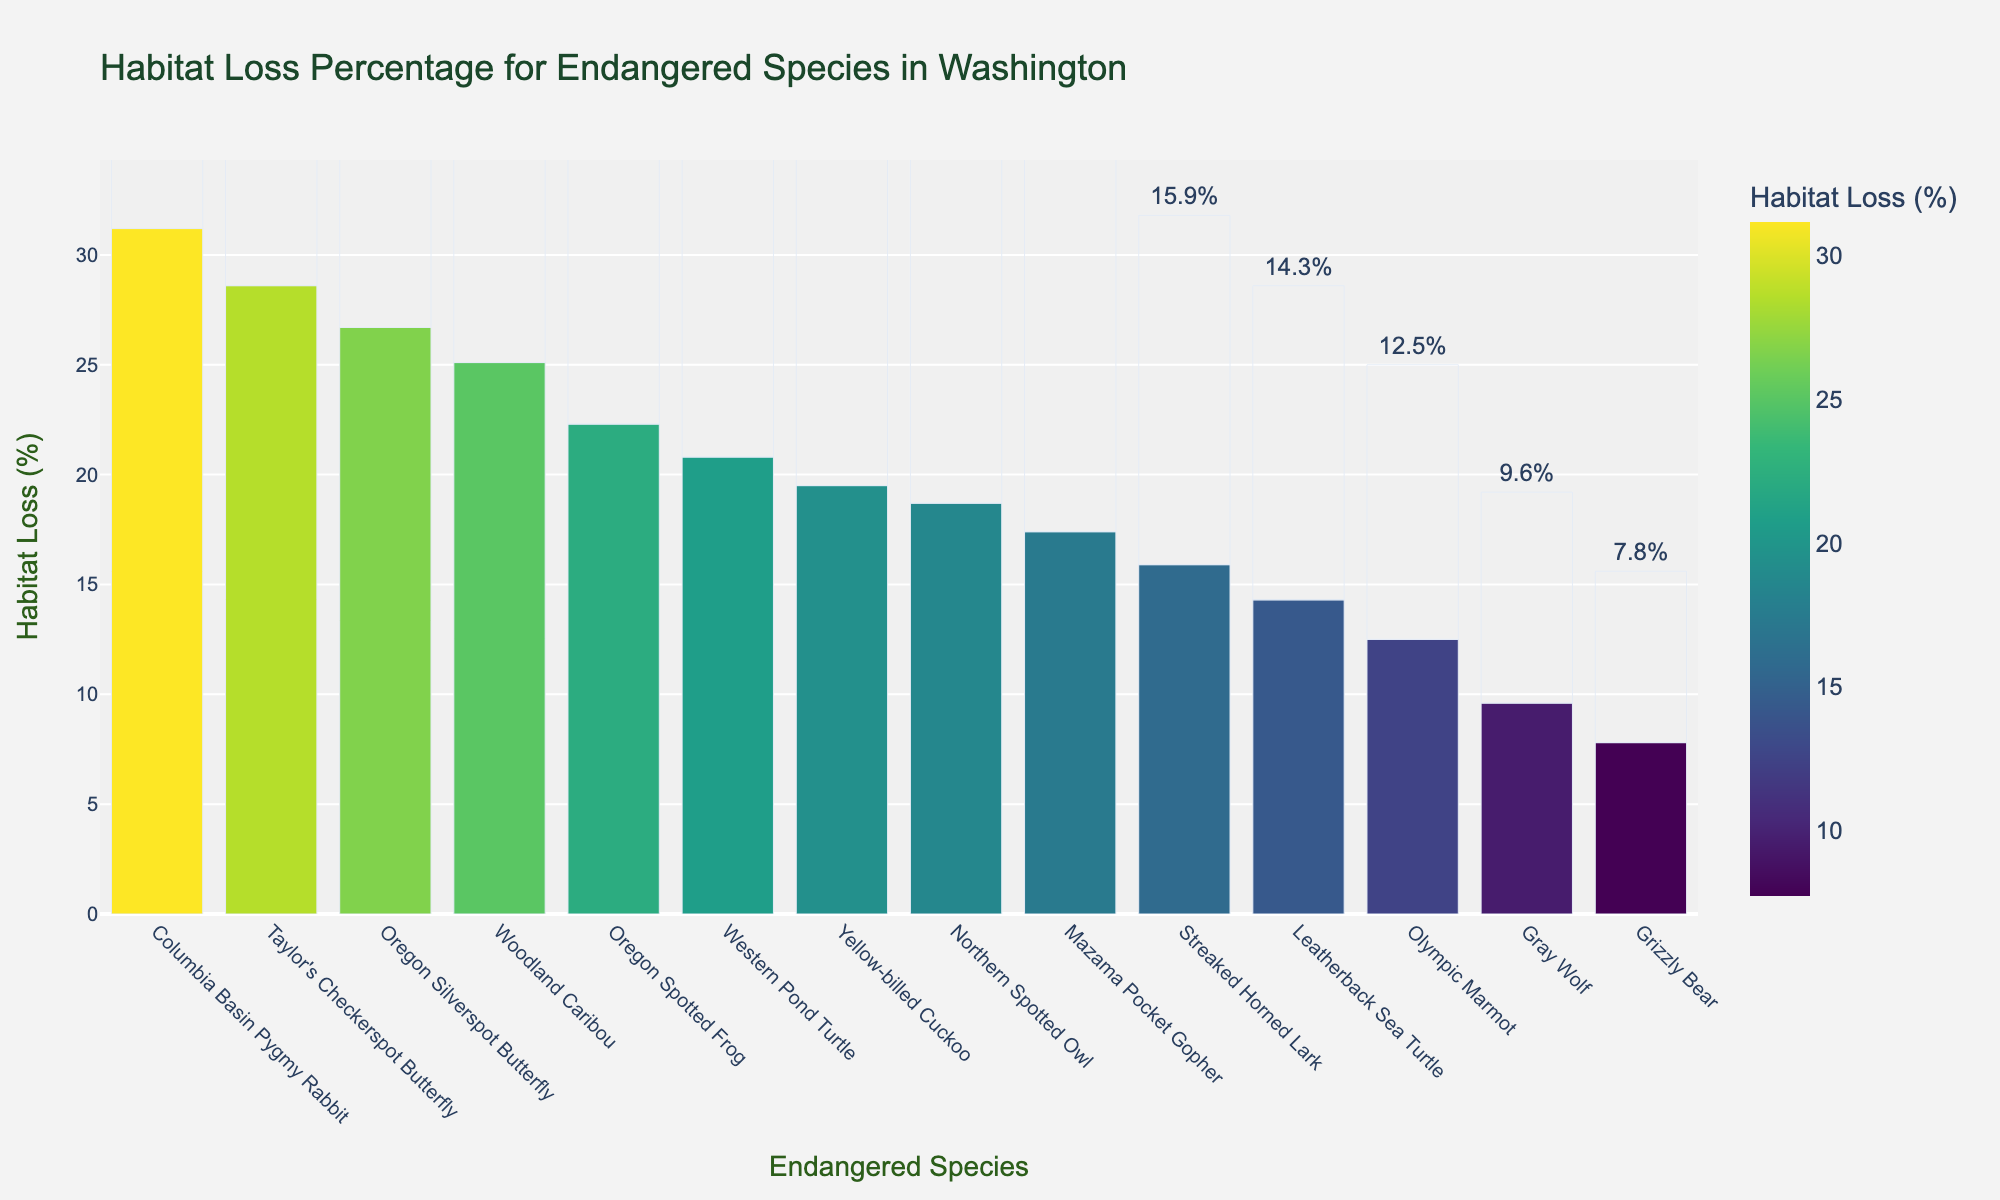Which species experienced the highest habitat loss? The figure shows the habitat loss percentages for each species, and Taylor's Checkerspot Butterfly has the tallest bar indicating the highest habitat loss.
Answer: Taylor's Checkerspot Butterfly Which species experienced the lowest habitat loss? The figure shows the habitat loss percentages for each species, and Grizzly Bear has the shortest bar indicating the lowest habitat loss.
Answer: Grizzly Bear Are there any species with habitat loss percentage between 20% and 25%? In the figure, Woodland Caribou has a habitat loss of 25.1%, Oregon Silverspot Butterfly has 26.7%, and Western Pond Turtle has 20.8%. Thus, Western Pond Turtle fits the criteria.
Answer: Western Pond Turtle How much greater is the habitat loss percentage for the Columbia Basin Pygmy Rabbit compared to the Gray Wolf? Columbia Basin Pygmy Rabbit has a habitat loss of 31.2%, and Gray Wolf has 9.6%. Subtracting these gives 31.2% - 9.6% = 21.6%.
Answer: 21.6% What is the average habitat loss percentage for all species listed? Adding all percentages together gives 272.4%, with 14 species in total. The average is 272.4% / 14 ≈ 19.5%.
Answer: 19.5% Which species have a habitat loss percentage higher than the average (19.5%)? The average habitat loss percentage is 19.5%. Species above this are Northern Spotted Owl (18.7%), Grizzly Bear (7.8%), etc. while considering the average.
Answer: Taylor's Checkerspot Butterfly, Columbia Basin Pygmy Rabbit, Oregon Silverspot Butterfly, Woodland Caribou, Oregon Spotted Frog, Yellow-billed Cuckoo, Western Pond Turtle Which color in the bar chart has the highest frequency among the bars representing habitat loss percentages above 25%? The bars with the highest habitat loss percentages (above 25%) will have the darkest shades of the color scale used (Viridis). Taylor's Checkerspot Butterfly (28.6%), Columbia Basin Pygmy Rabbit (31.2%), Oregon Silverspot Butterfly (26.7%), and Woodland Caribou (25.1%), all have dark colors.
Answer: Dark Green What is the median habitat loss percentage for the species listed? The sorted habitat loss percentages are (7.8, 9.6, 12.5, 14.3, 15.9, 17.4, 18.7, 19.5, 20.8, 22.3, 25.1, 26.7, 28.6, 31.2). The median is the average of the 7th and 8th values: (17.4 + 18.7)/2 = 18.05.
Answer: 18.05 